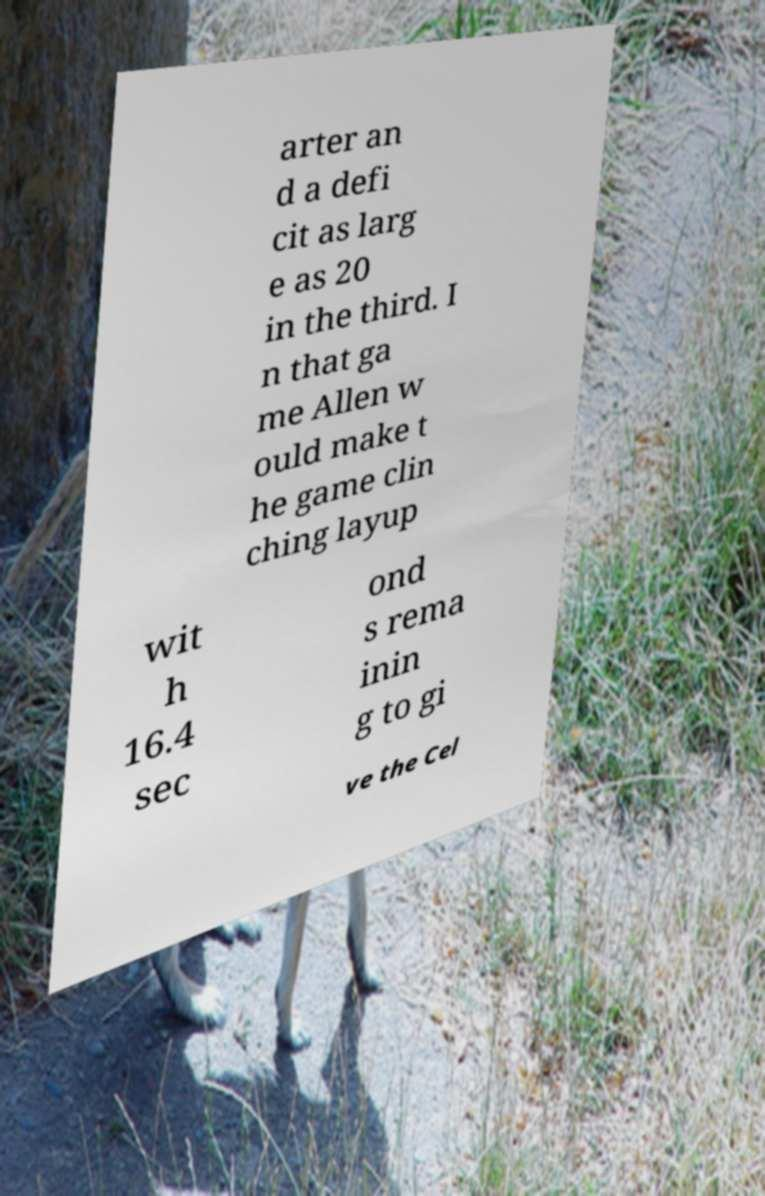Can you accurately transcribe the text from the provided image for me? arter an d a defi cit as larg e as 20 in the third. I n that ga me Allen w ould make t he game clin ching layup wit h 16.4 sec ond s rema inin g to gi ve the Cel 